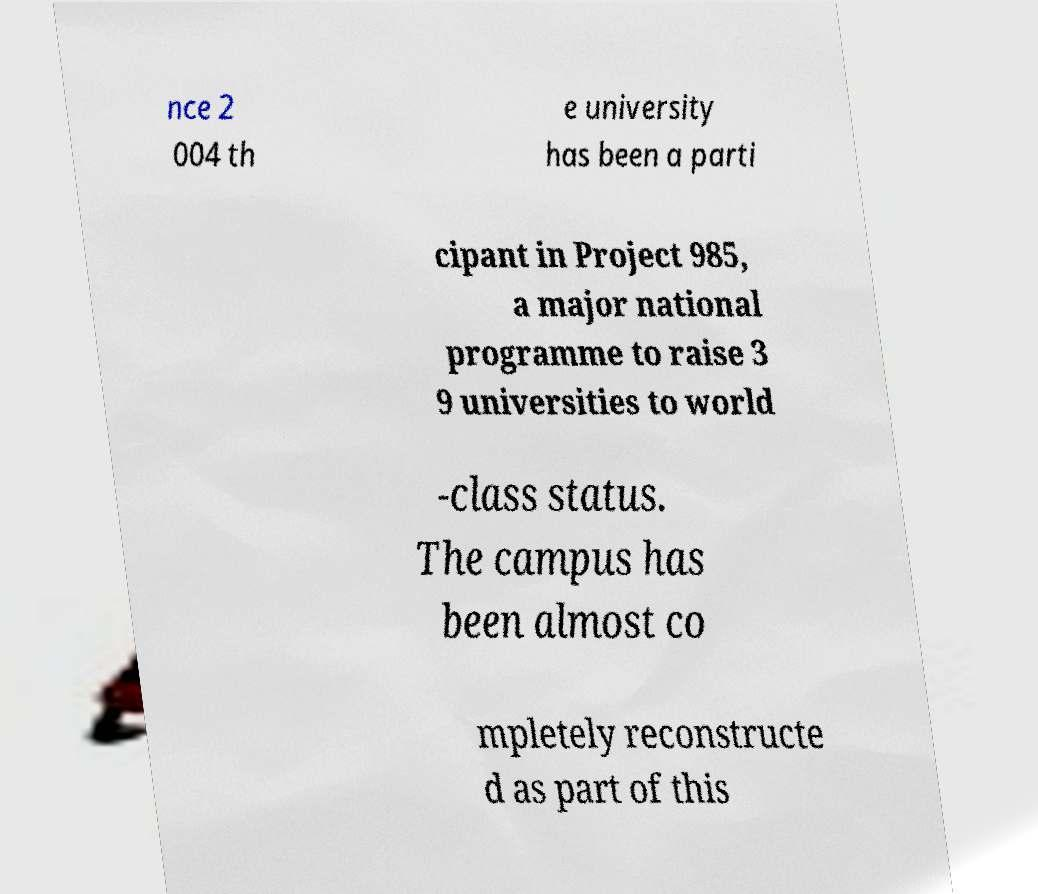What messages or text are displayed in this image? I need them in a readable, typed format. nce 2 004 th e university has been a parti cipant in Project 985, a major national programme to raise 3 9 universities to world -class status. The campus has been almost co mpletely reconstructe d as part of this 